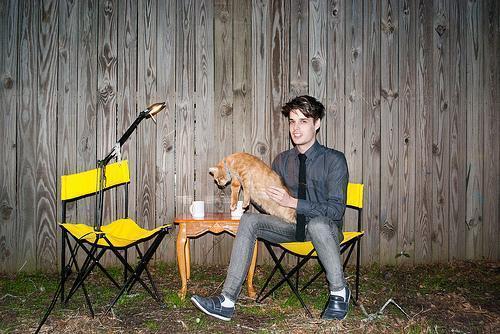How many coffee mugs are on the table?
Give a very brief answer. 2. 